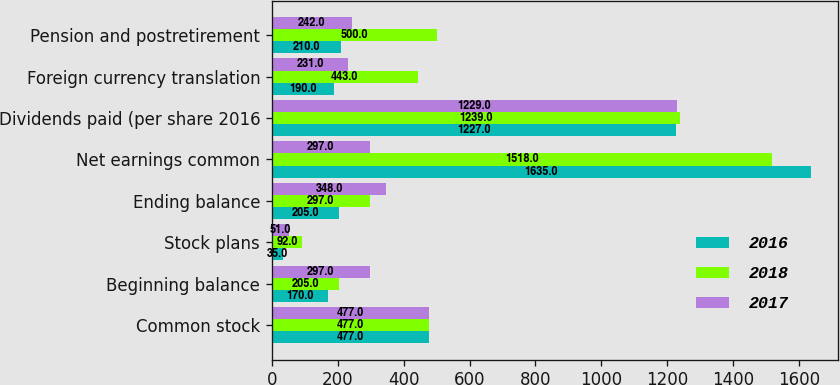Convert chart to OTSL. <chart><loc_0><loc_0><loc_500><loc_500><stacked_bar_chart><ecel><fcel>Common stock<fcel>Beginning balance<fcel>Stock plans<fcel>Ending balance<fcel>Net earnings common<fcel>Dividends paid (per share 2016<fcel>Foreign currency translation<fcel>Pension and postretirement<nl><fcel>2016<fcel>477<fcel>170<fcel>35<fcel>205<fcel>1635<fcel>1227<fcel>190<fcel>210<nl><fcel>2018<fcel>477<fcel>205<fcel>92<fcel>297<fcel>1518<fcel>1239<fcel>443<fcel>500<nl><fcel>2017<fcel>477<fcel>297<fcel>51<fcel>348<fcel>297<fcel>1229<fcel>231<fcel>242<nl></chart> 